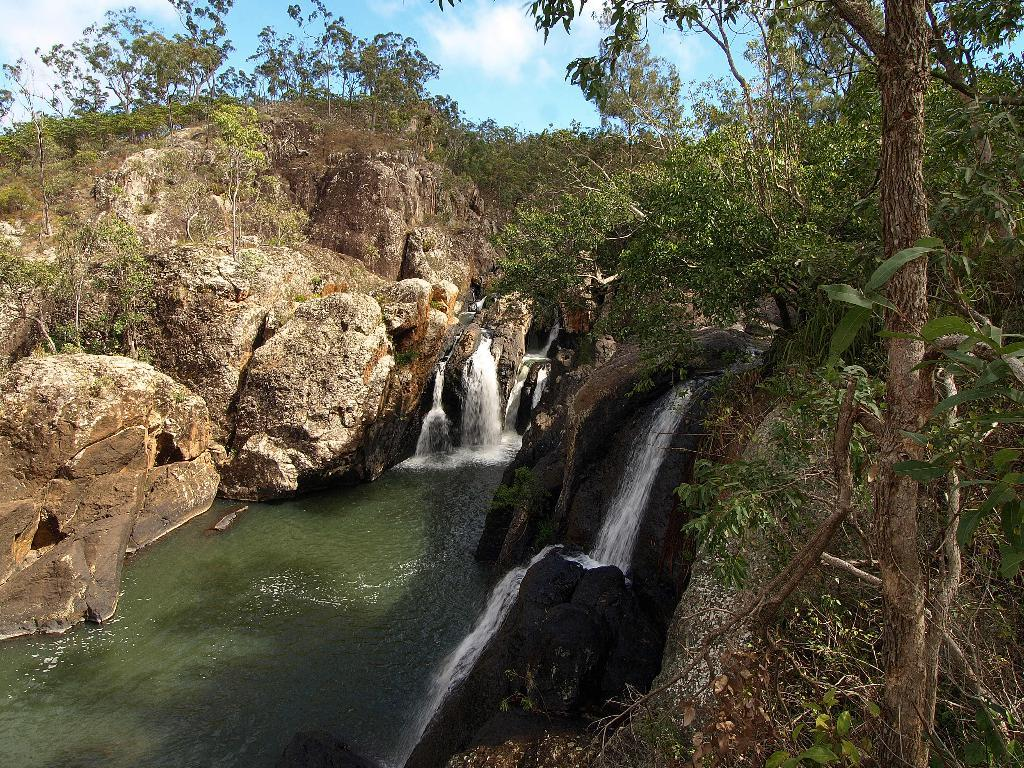What type of natural features can be seen in the image? There are trees and a waterfall in the image. What else can be found in the image besides trees and a waterfall? There are rocks in the image. What is visible in the background of the image? The sky is visible in the background of the image. What can be observed in the sky? Clouds are present in the sky. Can you tell me how many apples are being bitten by the aunt in the image? There is no aunt or apples present in the image, so this question cannot be answered. 